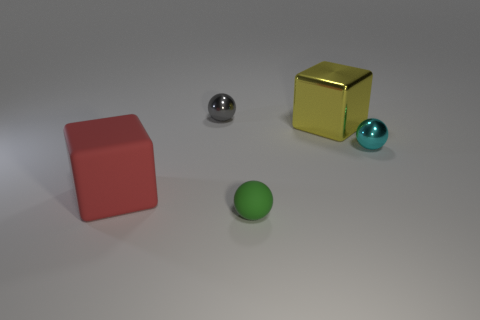There is another small metallic object that is the same shape as the cyan object; what is its color? The small metallic object that shares its shape with the cyan sphere is silver in color, with a reflective surface that mirrors the surrounding environment, giving off a sense of sleekness and simplicity. 